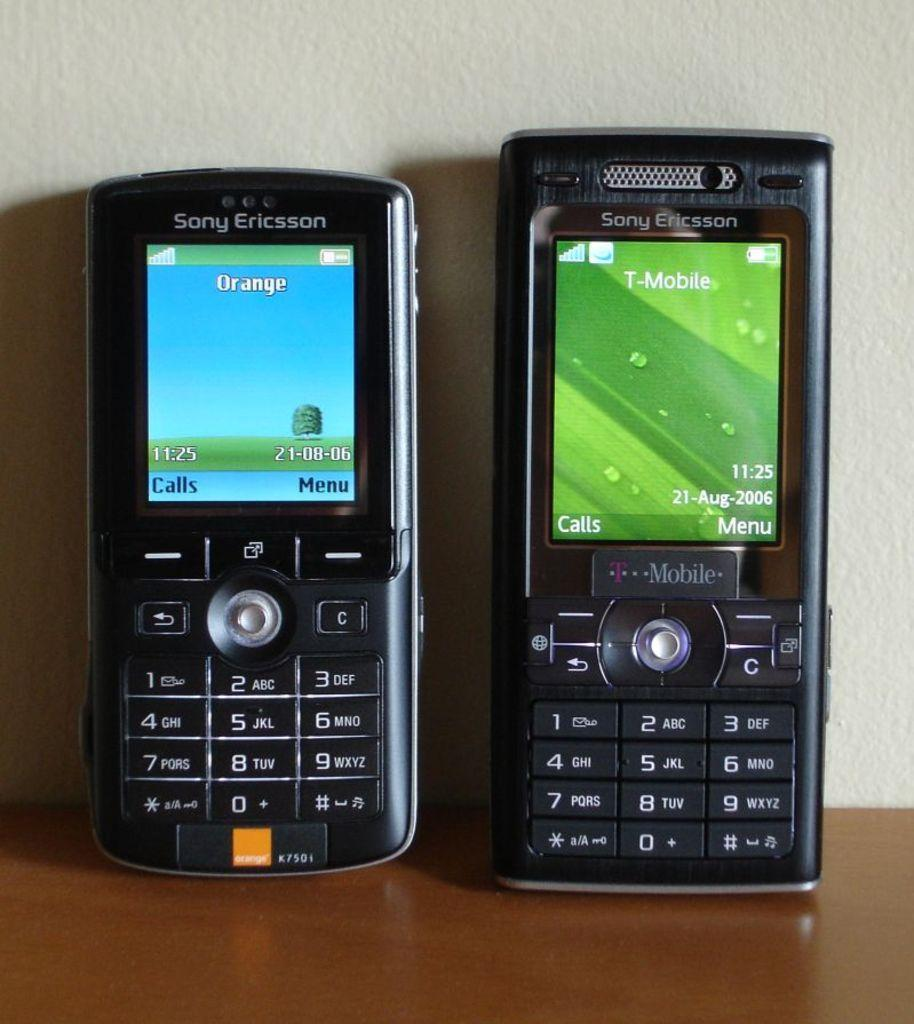What type of structure can be seen in the image? There is a wall in the image. What piece of furniture is present in the image? There is a table in the image. What objects are placed on the table? Two mobiles are placed on the table. What type of animal can be seen performing addition on the wall in the image? There is no animal present in the image, and no addition is being performed on the wall. 